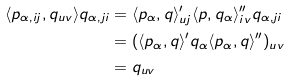Convert formula to latex. <formula><loc_0><loc_0><loc_500><loc_500>\langle p _ { \alpha , i j } , q _ { u v } \rangle q _ { \alpha , j i } & = \langle p _ { \alpha } , q \rangle ^ { \prime } _ { u j } \langle p , q _ { \alpha } \rangle ^ { \prime \prime } _ { i v } q _ { \alpha , j i } \\ & = ( \langle p _ { \alpha } , q \rangle ^ { \prime } q _ { \alpha } \langle p _ { \alpha } , q \rangle ^ { \prime \prime } ) _ { u v } \\ & = q _ { u v }</formula> 